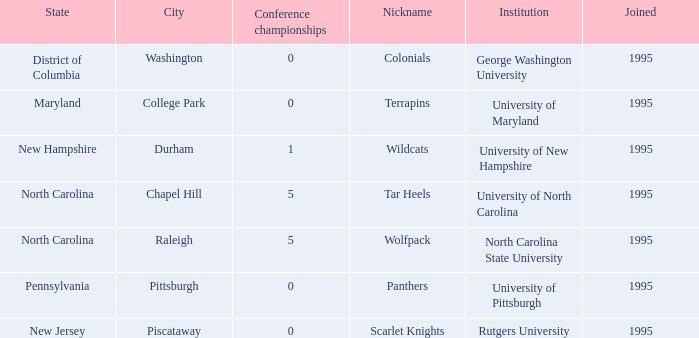What is the latest year joined with a Conference championships of 5, and an Institution of university of north carolina? 1995.0. 